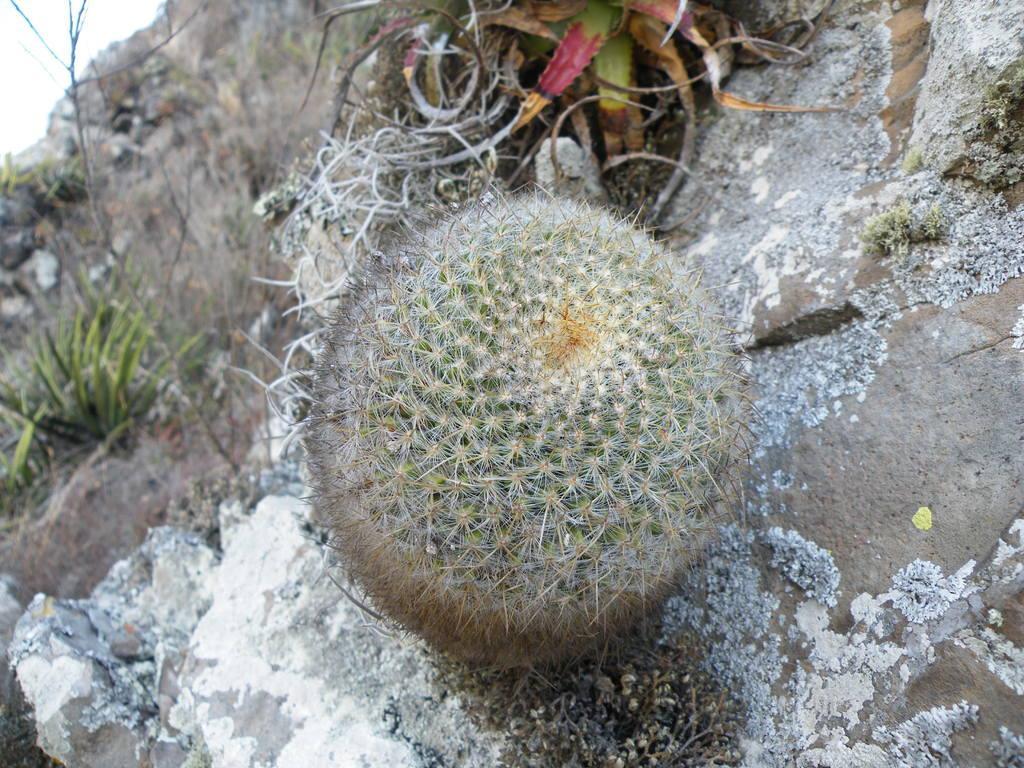How would you summarize this image in a sentence or two? In the foreground of this image, there is a desert plant and few stones. In the background, there are few plants and the sky. 